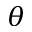Convert formula to latex. <formula><loc_0><loc_0><loc_500><loc_500>\theta</formula> 